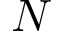Convert formula to latex. <formula><loc_0><loc_0><loc_500><loc_500>N</formula> 